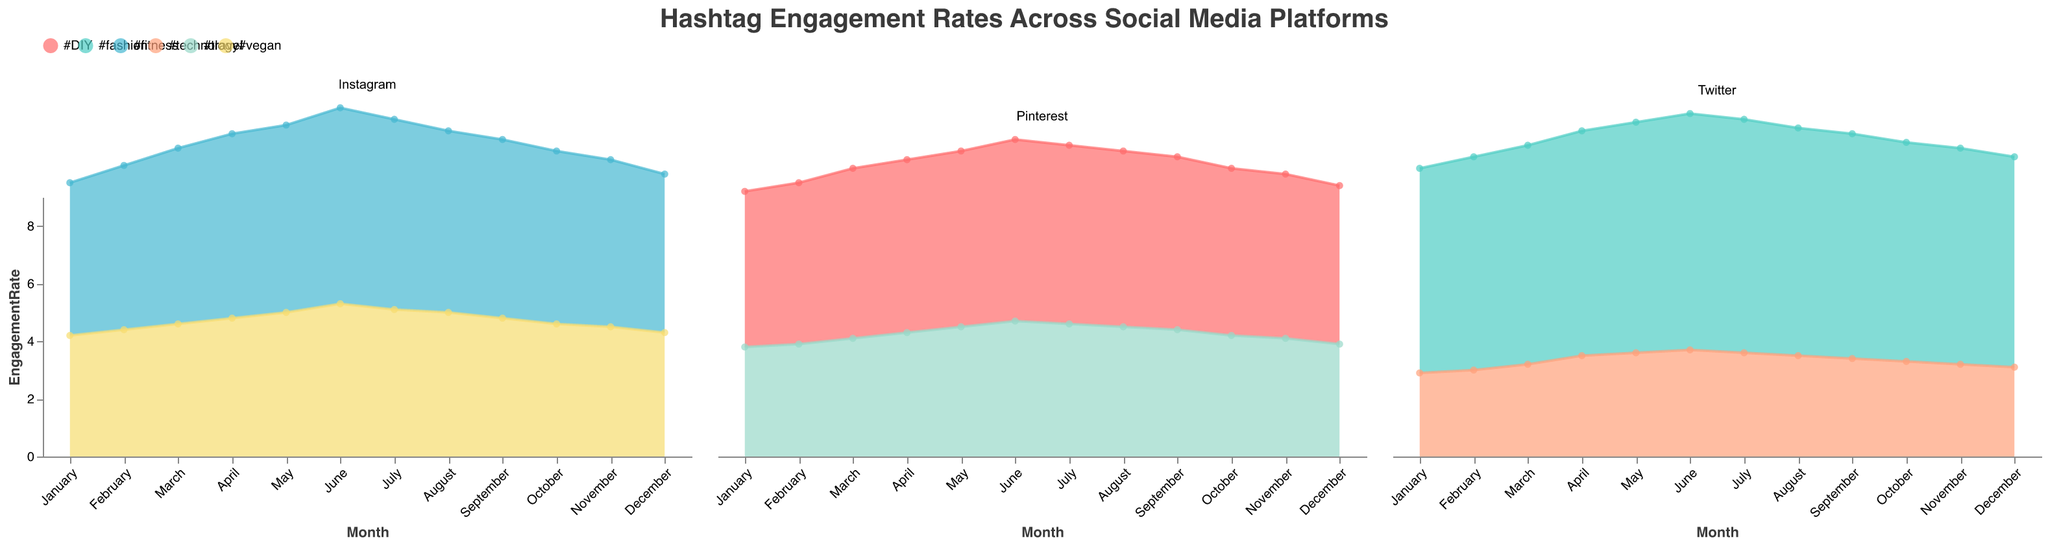What is the overall trend of the engagement rate for the #fitness hashtag on Instagram? The engagement rate for the #fitness hashtag on Instagram shows an increasing trend from January to June and then starts to decrease from July to December.
Answer: Increasing then decreasing Which hashtag on Pinterest had the highest engagement rate in June? By looking at the area representing June on the Pinterest subplot, the #DIY hashtag has a higher engagement rate of 6.3 compared to the #travel hashtag at 4.7.
Answer: #DIY How does the engagement rate of the #fashion hashtag on Twitter in November compare to December? In November, the engagement rate for #fashion on Twitter is 7.5, and in December, it is 7.3. Thus, the engagement rate in November is higher than in December.
Answer: November is higher What month had the lowest engagement rate for the #technology hashtag on Twitter? By examining the #technology hashtag on the Twitter subplot, December has the lowest engagement rate of 3.1.
Answer: December Which platform has the highest variability in engagement rates for its hashtags throughout the year? By comparing the ranges of engagement rates across all platforms, Twitter has the highest variability, especially for the #fashion hashtag, with rates ranging from 7.1 to 8.2.
Answer: Twitter Is the engagement rate of the #vegan hashtag on Instagram higher in March or September? In March, the engagement rate for #vegan on Instagram is 4.6, while in September it's 4.8. So, the engagement rate is higher in September.
Answer: September What is the average engagement rate of the #travel hashtag on Pinterest from May to August? The engagement rates for #travel on Pinterest from May to August are 4.5, 4.7, 4.6, and 4.5. The sum is 4.5 + 4.7 + 4.6 + 4.5 = 18.3, and the average is 18.3 / 4 = 4.575.
Answer: 4.575 Compare the engagement trends of the #DIY and #travel hashtags on Pinterest throughout the year. The #DIY hashtag shows a steady increase until June, followed by a gradual decrease. The #travel hashtag shows a more stable trend, with a slight overall increase peaking in June.
Answer: #DIY increases then decreases, #travel is stable What was the peak engagement rate for #fashion on Twitter, and in which month did it occur? The peak engagement rate for #fashion on Twitter is 8.2, which occurred in June.
Answer: 8.2 in June 